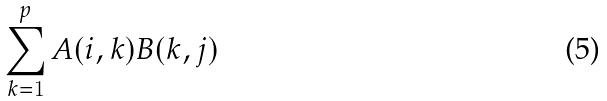Convert formula to latex. <formula><loc_0><loc_0><loc_500><loc_500>\sum _ { k = 1 } ^ { p } A ( i , k ) B ( k , j )</formula> 